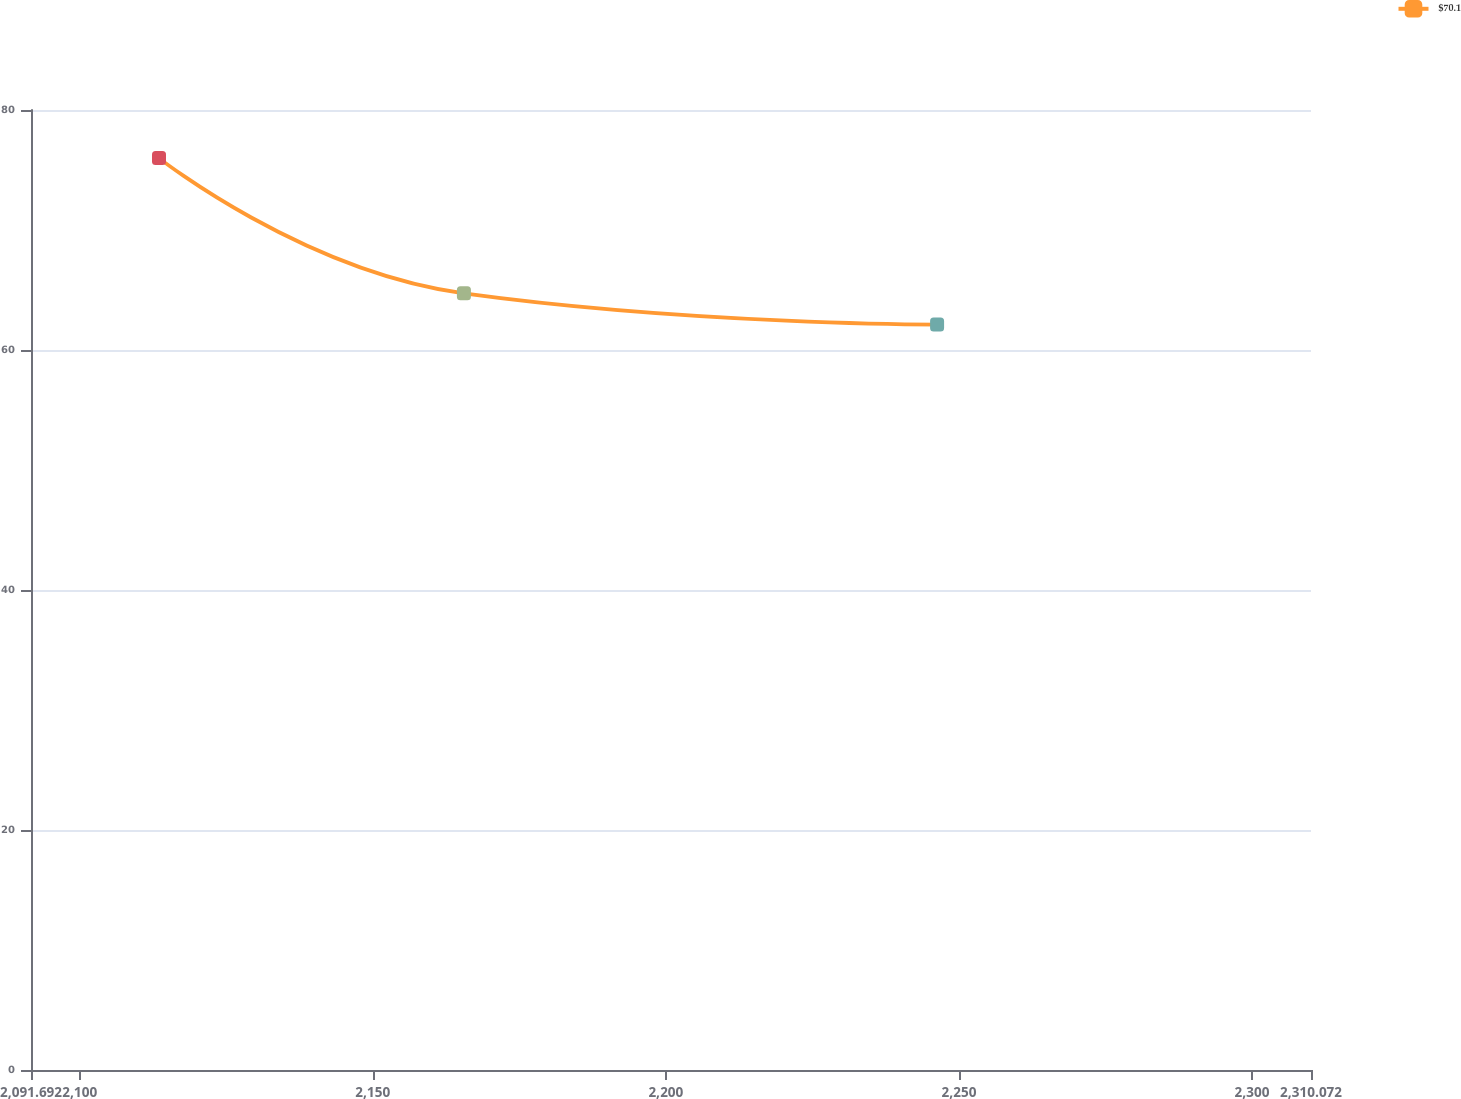Convert chart. <chart><loc_0><loc_0><loc_500><loc_500><line_chart><ecel><fcel>$70.1<nl><fcel>2113.53<fcel>75.99<nl><fcel>2165.55<fcel>64.72<nl><fcel>2246.28<fcel>62.12<nl><fcel>2331.91<fcel>60.58<nl></chart> 